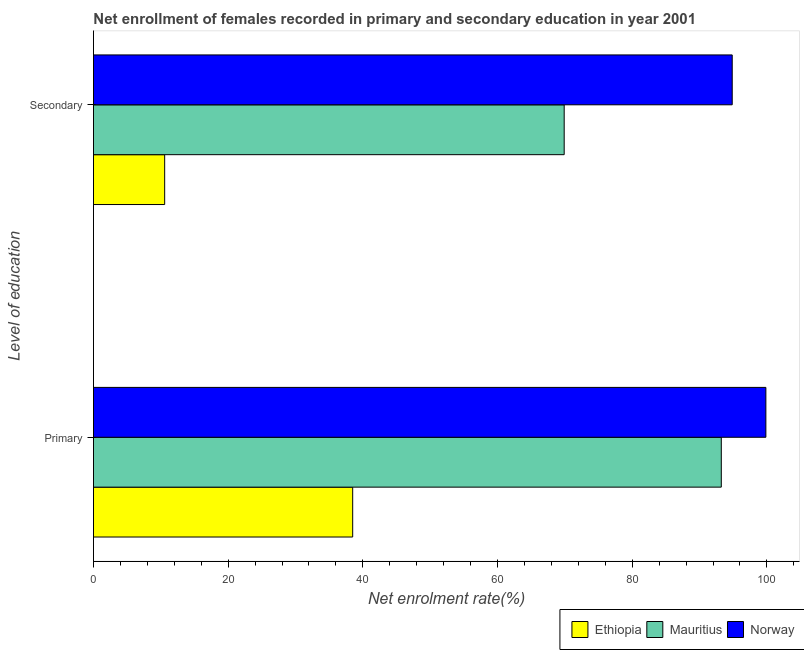How many groups of bars are there?
Ensure brevity in your answer.  2. Are the number of bars on each tick of the Y-axis equal?
Provide a short and direct response. Yes. How many bars are there on the 2nd tick from the bottom?
Keep it short and to the point. 3. What is the label of the 1st group of bars from the top?
Your answer should be very brief. Secondary. What is the enrollment rate in secondary education in Mauritius?
Keep it short and to the point. 69.9. Across all countries, what is the maximum enrollment rate in primary education?
Ensure brevity in your answer.  99.85. Across all countries, what is the minimum enrollment rate in primary education?
Your answer should be compact. 38.49. In which country was the enrollment rate in primary education maximum?
Offer a terse response. Norway. In which country was the enrollment rate in secondary education minimum?
Your response must be concise. Ethiopia. What is the total enrollment rate in secondary education in the graph?
Keep it short and to the point. 175.32. What is the difference between the enrollment rate in secondary education in Norway and that in Ethiopia?
Offer a very short reply. 84.28. What is the difference between the enrollment rate in secondary education in Mauritius and the enrollment rate in primary education in Norway?
Provide a succinct answer. -29.95. What is the average enrollment rate in secondary education per country?
Offer a very short reply. 58.44. What is the difference between the enrollment rate in primary education and enrollment rate in secondary education in Norway?
Give a very brief answer. 5. What is the ratio of the enrollment rate in secondary education in Ethiopia to that in Mauritius?
Provide a short and direct response. 0.15. Is the enrollment rate in primary education in Mauritius less than that in Ethiopia?
Ensure brevity in your answer.  No. What does the 1st bar from the bottom in Primary represents?
Provide a succinct answer. Ethiopia. Are all the bars in the graph horizontal?
Provide a succinct answer. Yes. How many countries are there in the graph?
Ensure brevity in your answer.  3. What is the difference between two consecutive major ticks on the X-axis?
Offer a very short reply. 20. Are the values on the major ticks of X-axis written in scientific E-notation?
Offer a very short reply. No. Where does the legend appear in the graph?
Your answer should be very brief. Bottom right. What is the title of the graph?
Offer a very short reply. Net enrollment of females recorded in primary and secondary education in year 2001. What is the label or title of the X-axis?
Provide a short and direct response. Net enrolment rate(%). What is the label or title of the Y-axis?
Your answer should be very brief. Level of education. What is the Net enrolment rate(%) in Ethiopia in Primary?
Ensure brevity in your answer.  38.49. What is the Net enrolment rate(%) in Mauritius in Primary?
Your answer should be very brief. 93.23. What is the Net enrolment rate(%) of Norway in Primary?
Offer a terse response. 99.85. What is the Net enrolment rate(%) of Ethiopia in Secondary?
Your answer should be compact. 10.57. What is the Net enrolment rate(%) in Mauritius in Secondary?
Ensure brevity in your answer.  69.9. What is the Net enrolment rate(%) of Norway in Secondary?
Ensure brevity in your answer.  94.85. Across all Level of education, what is the maximum Net enrolment rate(%) in Ethiopia?
Provide a short and direct response. 38.49. Across all Level of education, what is the maximum Net enrolment rate(%) of Mauritius?
Your answer should be compact. 93.23. Across all Level of education, what is the maximum Net enrolment rate(%) of Norway?
Make the answer very short. 99.85. Across all Level of education, what is the minimum Net enrolment rate(%) in Ethiopia?
Provide a short and direct response. 10.57. Across all Level of education, what is the minimum Net enrolment rate(%) in Mauritius?
Offer a very short reply. 69.9. Across all Level of education, what is the minimum Net enrolment rate(%) of Norway?
Provide a short and direct response. 94.85. What is the total Net enrolment rate(%) in Ethiopia in the graph?
Ensure brevity in your answer.  49.07. What is the total Net enrolment rate(%) in Mauritius in the graph?
Your response must be concise. 163.13. What is the total Net enrolment rate(%) of Norway in the graph?
Offer a very short reply. 194.7. What is the difference between the Net enrolment rate(%) of Ethiopia in Primary and that in Secondary?
Your response must be concise. 27.92. What is the difference between the Net enrolment rate(%) of Mauritius in Primary and that in Secondary?
Offer a terse response. 23.33. What is the difference between the Net enrolment rate(%) in Norway in Primary and that in Secondary?
Provide a succinct answer. 5. What is the difference between the Net enrolment rate(%) in Ethiopia in Primary and the Net enrolment rate(%) in Mauritius in Secondary?
Offer a very short reply. -31.41. What is the difference between the Net enrolment rate(%) of Ethiopia in Primary and the Net enrolment rate(%) of Norway in Secondary?
Ensure brevity in your answer.  -56.36. What is the difference between the Net enrolment rate(%) in Mauritius in Primary and the Net enrolment rate(%) in Norway in Secondary?
Offer a very short reply. -1.62. What is the average Net enrolment rate(%) of Ethiopia per Level of education?
Offer a very short reply. 24.53. What is the average Net enrolment rate(%) of Mauritius per Level of education?
Offer a terse response. 81.57. What is the average Net enrolment rate(%) of Norway per Level of education?
Your answer should be compact. 97.35. What is the difference between the Net enrolment rate(%) in Ethiopia and Net enrolment rate(%) in Mauritius in Primary?
Keep it short and to the point. -54.74. What is the difference between the Net enrolment rate(%) of Ethiopia and Net enrolment rate(%) of Norway in Primary?
Keep it short and to the point. -61.36. What is the difference between the Net enrolment rate(%) of Mauritius and Net enrolment rate(%) of Norway in Primary?
Give a very brief answer. -6.62. What is the difference between the Net enrolment rate(%) in Ethiopia and Net enrolment rate(%) in Mauritius in Secondary?
Ensure brevity in your answer.  -59.33. What is the difference between the Net enrolment rate(%) of Ethiopia and Net enrolment rate(%) of Norway in Secondary?
Ensure brevity in your answer.  -84.28. What is the difference between the Net enrolment rate(%) of Mauritius and Net enrolment rate(%) of Norway in Secondary?
Keep it short and to the point. -24.95. What is the ratio of the Net enrolment rate(%) in Ethiopia in Primary to that in Secondary?
Your answer should be very brief. 3.64. What is the ratio of the Net enrolment rate(%) in Mauritius in Primary to that in Secondary?
Offer a terse response. 1.33. What is the ratio of the Net enrolment rate(%) of Norway in Primary to that in Secondary?
Your answer should be very brief. 1.05. What is the difference between the highest and the second highest Net enrolment rate(%) of Ethiopia?
Your response must be concise. 27.92. What is the difference between the highest and the second highest Net enrolment rate(%) of Mauritius?
Give a very brief answer. 23.33. What is the difference between the highest and the second highest Net enrolment rate(%) of Norway?
Your answer should be very brief. 5. What is the difference between the highest and the lowest Net enrolment rate(%) of Ethiopia?
Keep it short and to the point. 27.92. What is the difference between the highest and the lowest Net enrolment rate(%) of Mauritius?
Provide a succinct answer. 23.33. What is the difference between the highest and the lowest Net enrolment rate(%) of Norway?
Provide a short and direct response. 5. 